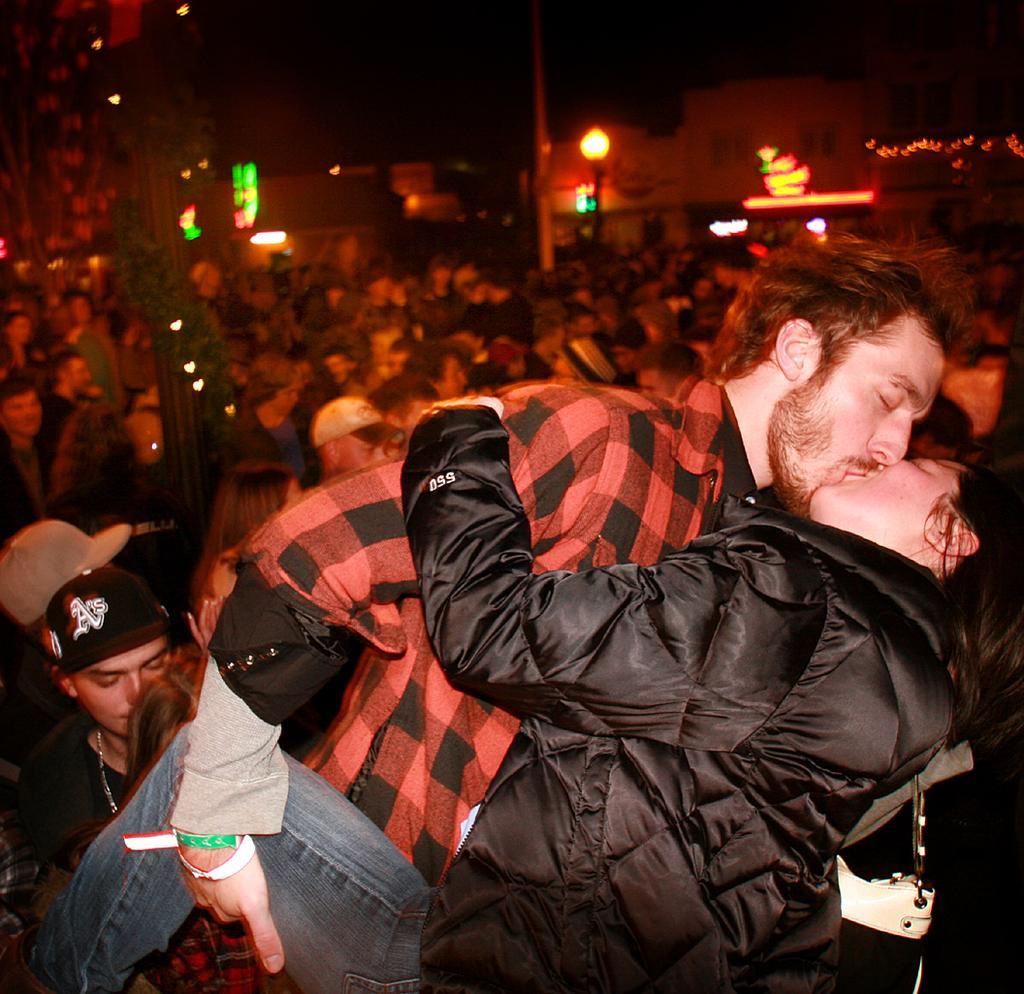Could you give a brief overview of what you see in this image? In this image we can see a few people, two of them are kissing, there are houses, lights, there is a creeper around a pole, and the background is dark. 